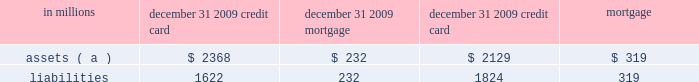Note 10 loan sales and securitizations loan sales we sell residential and commercial mortgage loans in loan securitization transactions sponsored by government national mortgage association ( gnma ) , fnma , and fhlmc and in certain instances to other third-party investors .
Gnma , fnma , and the fhlmc securitize our transferred loans into mortgage-backed securities for sale into the secondary market .
Generally , we do not retain any interest in the transferred loans other than mortgage servicing rights .
Refer to note 9 goodwill and other intangible assets for further discussion on our residential and commercial mortgage servicing rights assets .
During 2009 , residential and commercial mortgage loans sold totaled $ 19.8 billion and $ 5.7 billion , respectively .
During 2008 , commercial mortgage loans sold totaled $ 3.1 billion .
There were no residential mortgage loans sales in 2008 as these activities were obtained through our acquisition of national city .
Our continuing involvement in these loan sales consists primarily of servicing and limited repurchase obligations for loan and servicer breaches in representations and warranties .
Generally , we hold a cleanup call repurchase option for loans sold with servicing retained to the other third-party investors .
In certain circumstances as servicer , we advance principal and interest payments to the gses and other third-party investors and also may make collateral protection advances .
Our risk of loss in these servicing advances has historically been minimal .
We maintain a liability for estimated losses on loans expected to be repurchased as a result of breaches in loan and servicer representations and warranties .
We have also entered into recourse arrangements associated with commercial mortgage loans sold to fnma and fhlmc .
Refer to note 25 commitments and guarantees for further discussion on our repurchase liability and recourse arrangements .
Our maximum exposure to loss in our loan sale activities is limited to these repurchase and recourse obligations .
In addition , for certain loans transferred in the gnma and fnma transactions , we hold an option to repurchase individual delinquent loans that meet certain criteria .
Without prior authorization from these gses , this option gives pnc the ability to repurchase the delinquent loan at par .
Under gaap , once we have the unilateral ability to repurchase the delinquent loan , effective control over the loan has been regained and we are required to recognize the loan and a corresponding repurchase liability on the balance sheet regardless of our intent to repurchase the loan .
At december 31 , 2009 and december 31 , 2008 , the balance of our repurchase option asset and liability totaled $ 577 million and $ 476 million , respectively .
Securitizations in securitizations , loans are typically transferred to a qualifying special purpose entity ( qspe ) that is demonstrably distinct from the transferor to transfer the risk from our consolidated balance sheet .
A qspe is a bankruptcy-remote trust allowed to perform only certain passive activities .
In addition , these entities are self-liquidating and in certain instances are structured as real estate mortgage investment conduits ( remics ) for tax purposes .
The qspes are generally financed by issuing certificates for various levels of senior and subordinated tranches .
Qspes are exempt from consolidation provided certain conditions are met .
Our securitization activities were primarily obtained through our acquisition of national city .
Credit card receivables , automobile , and residential mortgage loans were securitized through qspes sponsored by ncb .
These qspes were financed primarily through the issuance and sale of beneficial interests to independent third parties and were not consolidated on our balance sheet at december 31 , 2009 or december 31 , 2008 .
However , see note 1 accounting policies regarding accounting guidance that impacts the accounting for these qspes effective january 1 , 2010 .
Qualitative and quantitative information about the securitization qspes and our retained interests in these transactions follow .
The following summarizes the assets and liabilities of the securitization qspes associated with securitization transactions that were outstanding at december 31 , 2009. .
( a ) represents period-end outstanding principal balances of loans transferred to the securitization qspes .
Credit card loans at december 31 , 2009 , the credit card securitization series 2005-1 , 2006-1 , 2007-1 , and 2008-3 were outstanding .
During the fourth quarter of 2009 , the 2008-1 and 2008-2 credit card securitization series matured .
Our continuing involvement in the securitized credit card receivables consists primarily of servicing and our holding of certain retained interests .
Servicing fees earned approximate current market rates for servicing fees ; therefore , no servicing asset or liability is recognized .
We hold a clean-up call repurchase option to the extent a securitization series extends past its scheduled note principal payoff date .
To the extent this occurs , the clean-up call option is triggered when the principal balance of the asset- backed notes of any series reaches 5% ( 5 % ) of the initial principal balance of the asset-backed notes issued at the securitization .
In 2009 what was the percentage of the total loans sold that was from commercial mortagages? 
Computations: (5.7 / (19.8 + 5.7))
Answer: 0.22353. 